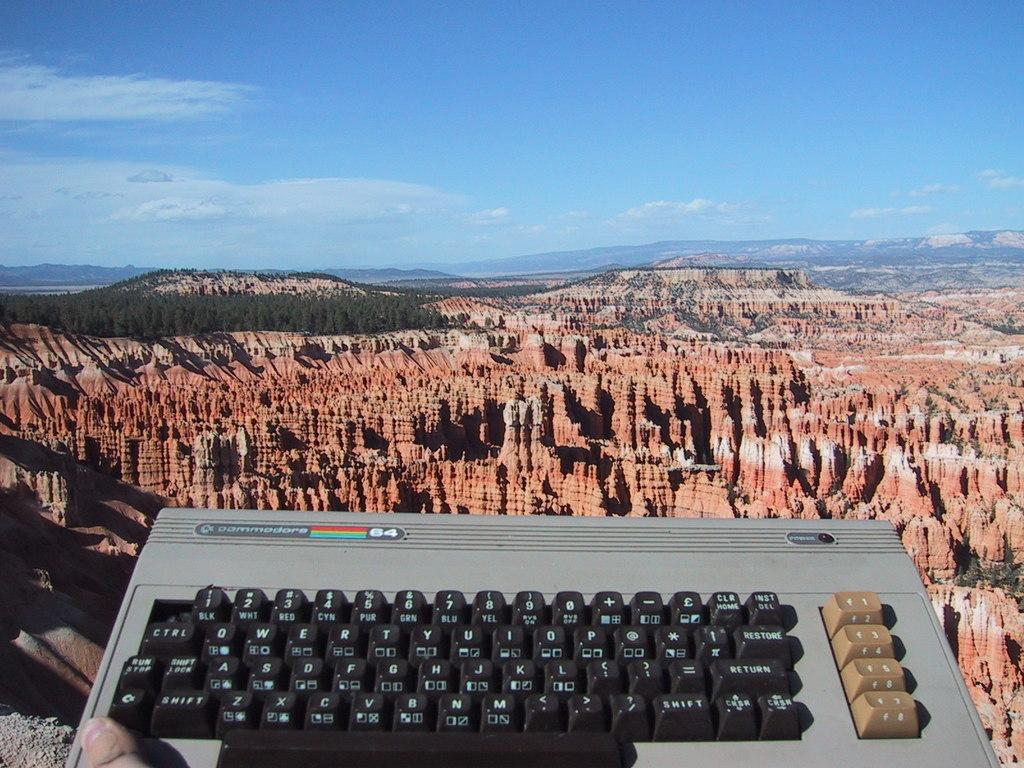<image>
Relay a brief, clear account of the picture shown. A commodore computer keyboard is being held up near a big photo of the Grand Canyon. 